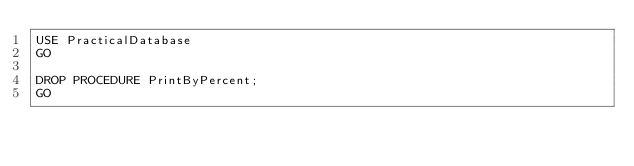<code> <loc_0><loc_0><loc_500><loc_500><_SQL_>USE PracticalDatabase
GO

DROP PROCEDURE PrintByPercent;
GO</code> 